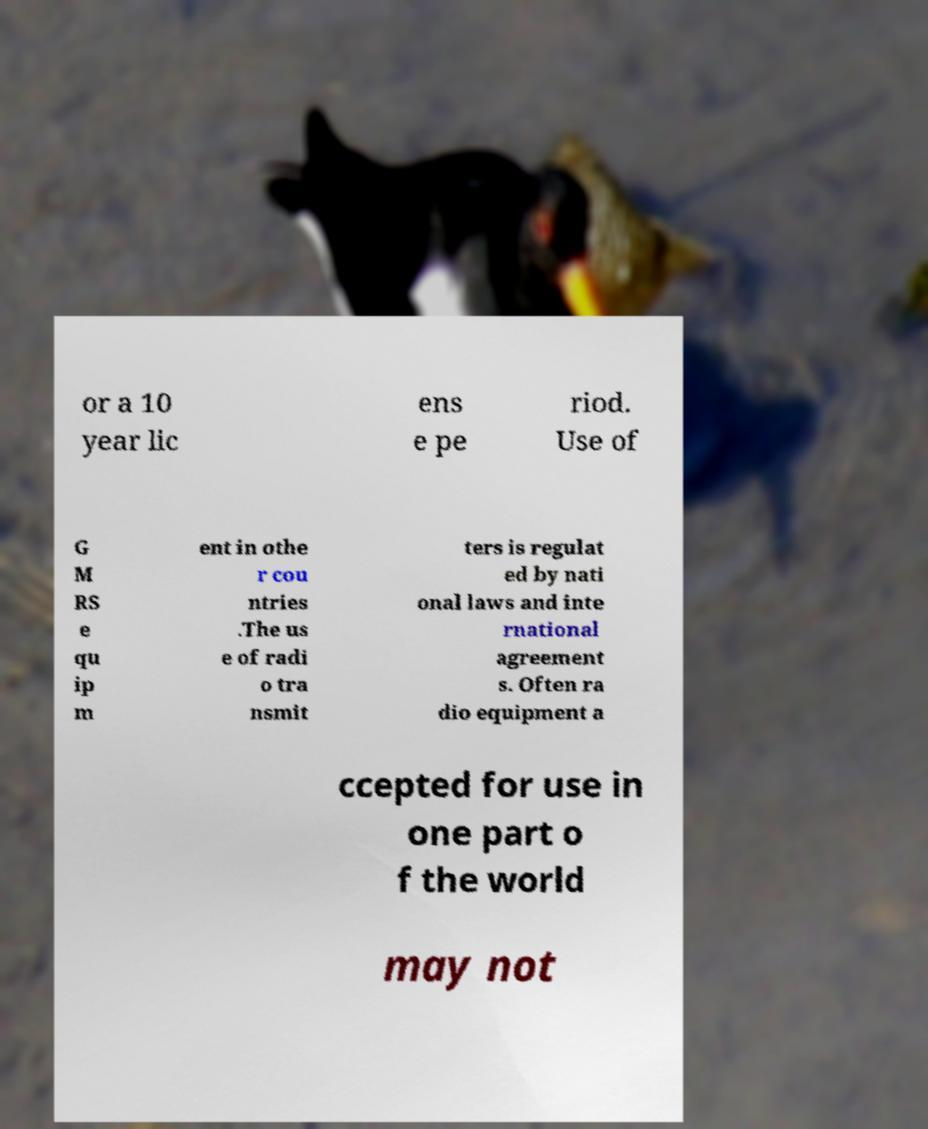Please read and relay the text visible in this image. What does it say? or a 10 year lic ens e pe riod. Use of G M RS e qu ip m ent in othe r cou ntries .The us e of radi o tra nsmit ters is regulat ed by nati onal laws and inte rnational agreement s. Often ra dio equipment a ccepted for use in one part o f the world may not 